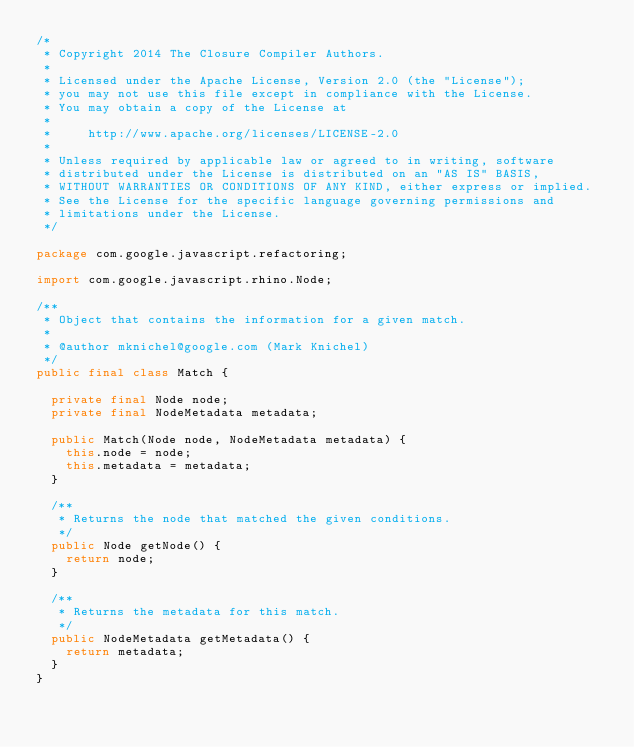Convert code to text. <code><loc_0><loc_0><loc_500><loc_500><_Java_>/*
 * Copyright 2014 The Closure Compiler Authors.
 *
 * Licensed under the Apache License, Version 2.0 (the "License");
 * you may not use this file except in compliance with the License.
 * You may obtain a copy of the License at
 *
 *     http://www.apache.org/licenses/LICENSE-2.0
 *
 * Unless required by applicable law or agreed to in writing, software
 * distributed under the License is distributed on an "AS IS" BASIS,
 * WITHOUT WARRANTIES OR CONDITIONS OF ANY KIND, either express or implied.
 * See the License for the specific language governing permissions and
 * limitations under the License.
 */

package com.google.javascript.refactoring;

import com.google.javascript.rhino.Node;

/**
 * Object that contains the information for a given match.
 *
 * @author mknichel@google.com (Mark Knichel)
 */
public final class Match {

  private final Node node;
  private final NodeMetadata metadata;

  public Match(Node node, NodeMetadata metadata) {
    this.node = node;
    this.metadata = metadata;
  }

  /**
   * Returns the node that matched the given conditions.
   */
  public Node getNode() {
    return node;
  }

  /**
   * Returns the metadata for this match.
   */
  public NodeMetadata getMetadata() {
    return metadata;
  }
}
</code> 